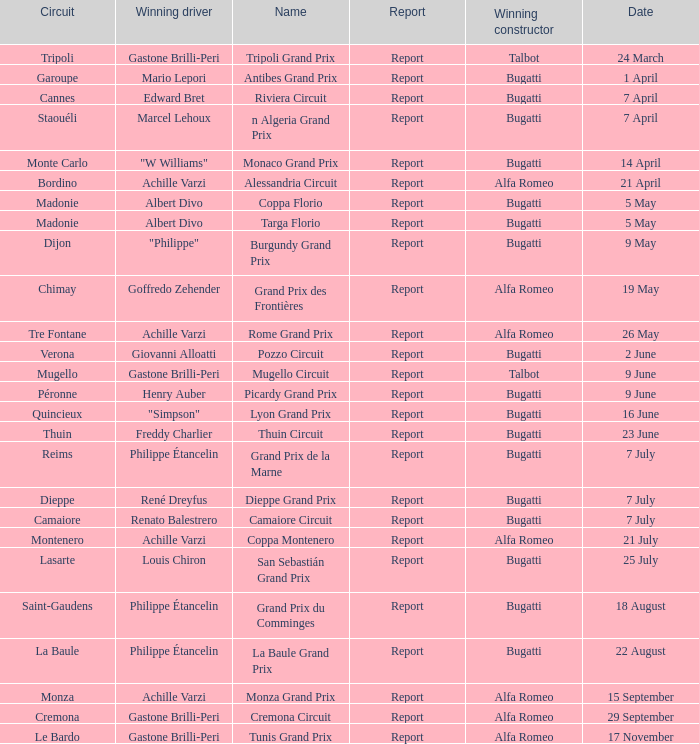What Winning driver has a Winning constructor of talbot? Gastone Brilli-Peri, Gastone Brilli-Peri. 